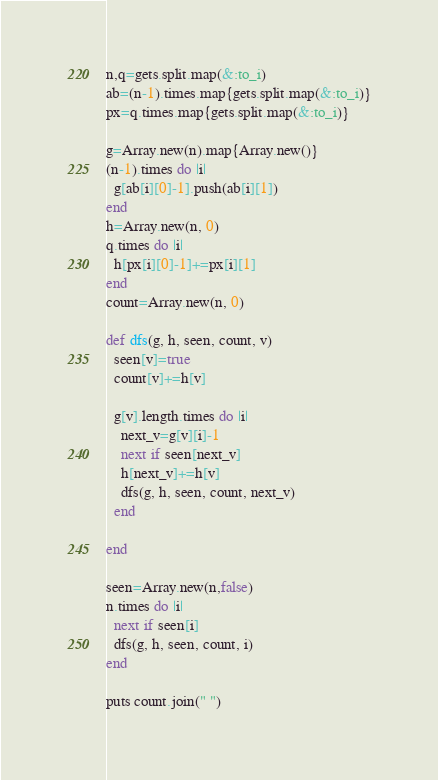Convert code to text. <code><loc_0><loc_0><loc_500><loc_500><_Ruby_>n,q=gets.split.map(&:to_i)
ab=(n-1).times.map{gets.split.map(&:to_i)}
px=q.times.map{gets.split.map(&:to_i)}

g=Array.new(n).map{Array.new()}
(n-1).times do |i|
  g[ab[i][0]-1].push(ab[i][1])
end
h=Array.new(n, 0)
q.times do |i|
  h[px[i][0]-1]+=px[i][1]
end
count=Array.new(n, 0)

def dfs(g, h, seen, count, v)
  seen[v]=true
  count[v]+=h[v]

  g[v].length.times do |i|
    next_v=g[v][i]-1
    next if seen[next_v]
    h[next_v]+=h[v]
    dfs(g, h, seen, count, next_v)
  end

end

seen=Array.new(n,false)
n.times do |i|
  next if seen[i]
  dfs(g, h, seen, count, i)
end

puts count.join(" ")
</code> 